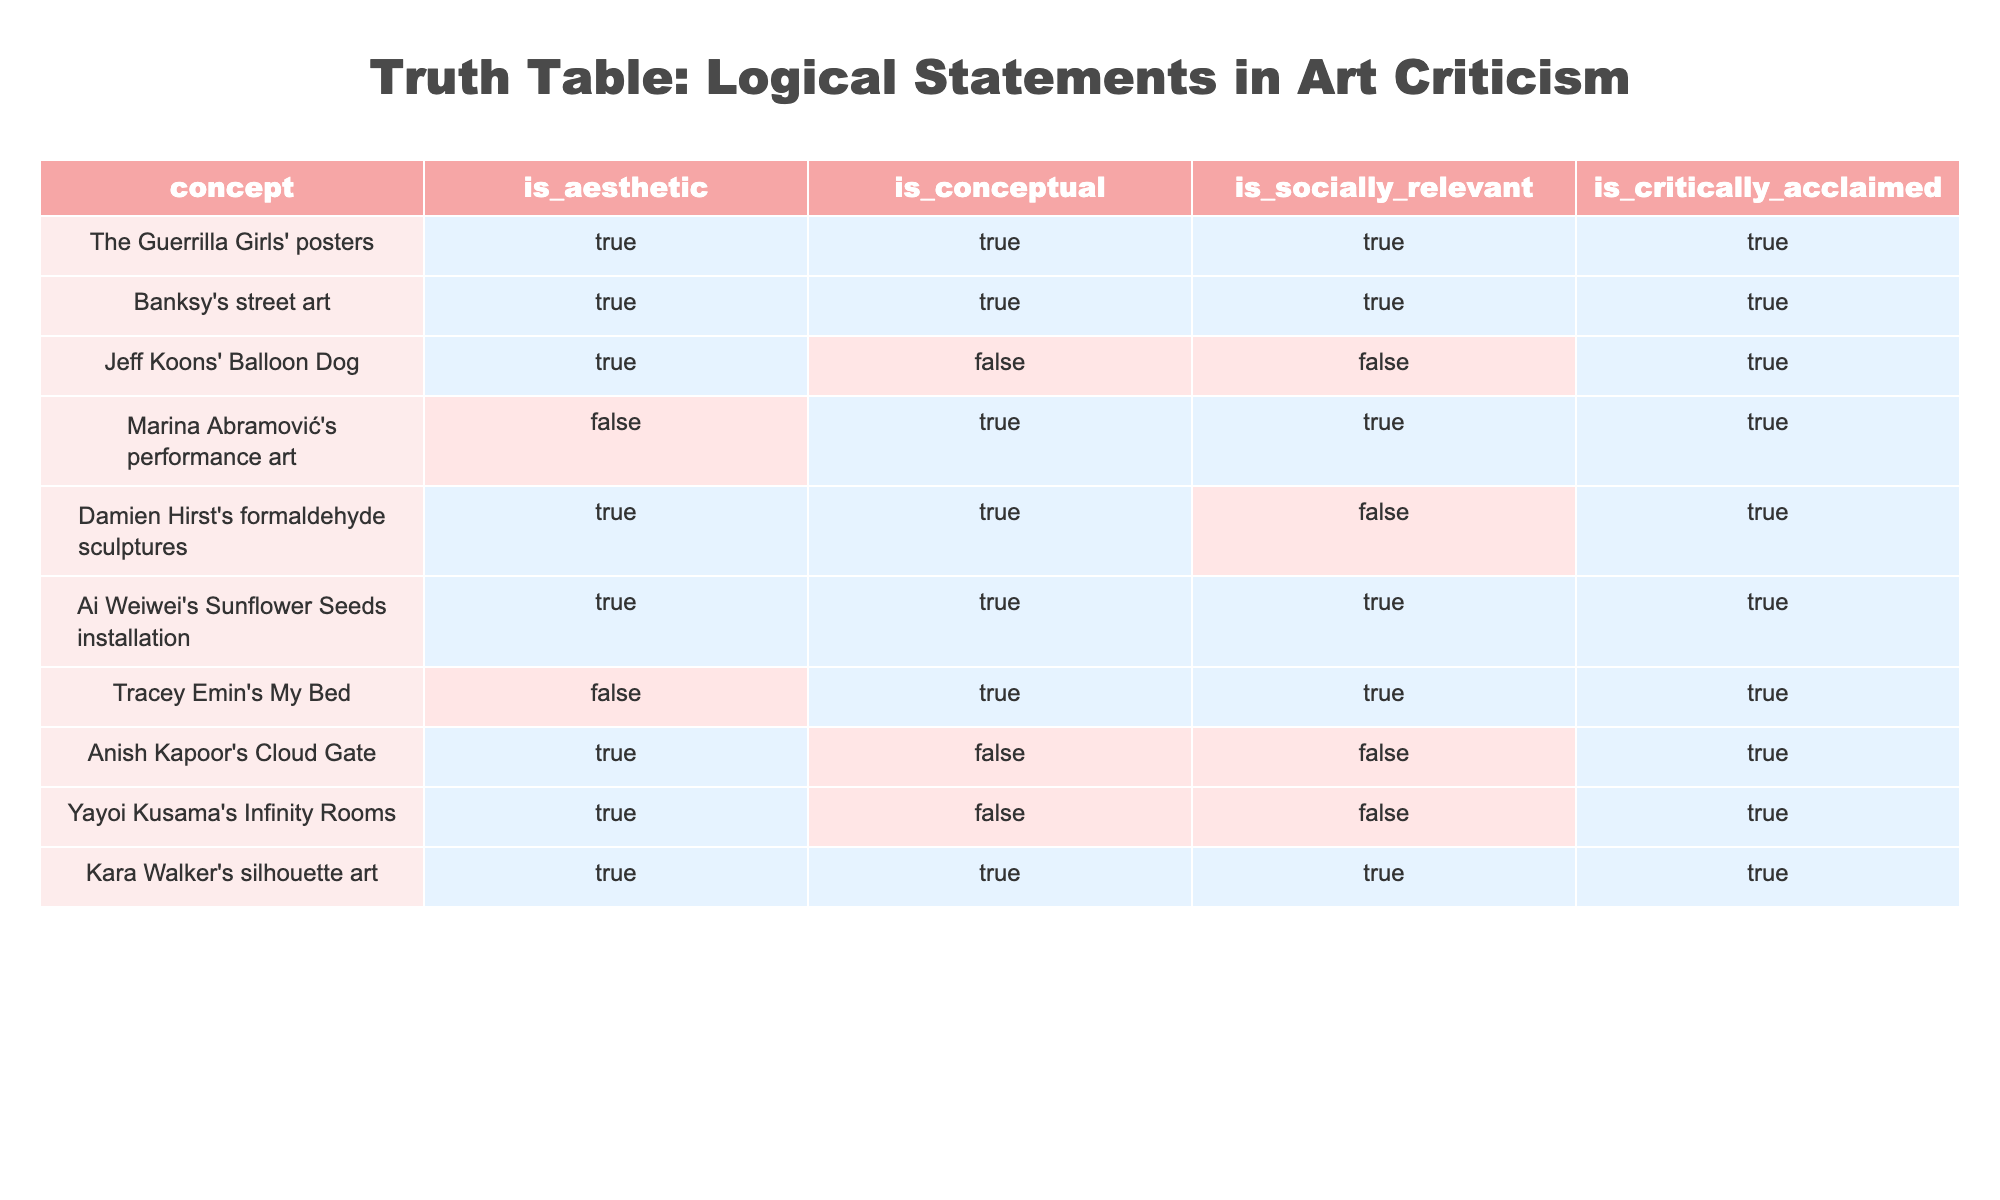What concepts are both aesthetic and socially relevant? To find the concepts that are both aesthetic and socially relevant, I check the columns for "is_aesthetic" and "is_socially_relevant". These must both have a value of true. The rows that meet this criterion are "The Guerrilla Girls' posters", "Banksy's street art", "Ai Weiwei's Sunflower Seeds installation", and "Kara Walker's silhouette art".
Answer: The Guerrilla Girls' posters, Banksy's street art, Ai Weiwei's Sunflower Seeds installation, Kara Walker's silhouette art How many concepts are not considered aesthetic? I look at the "is_aesthetic" column for the concepts that are marked false. These are "Marina Abramović's performance art", "Tracey Emin's My Bed", "Jeff Koons' Balloon Dog", "Anish Kapoor's Cloud Gate", and "Yayoi Kusama's Infinity Rooms". Counting them gives a total of five concepts.
Answer: 5 Is "Damien Hirst's formaldehyde sculptures" critically acclaimed? I reference the "is_critically_acclaimed" column for the row corresponding to "Damien Hirst's formaldehyde sculptures". It shows a value of true, indicating that it is critically acclaimed.
Answer: Yes Which concept has the highest number of true values across the "is_aesthetic", "is_conceptual", "is_socially_relevant", and "is_critically_acclaimed" columns? I count the true values for each concept in those four categories. "The Guerrilla Girls' posters", "Banksy's street art", "Ai Weiwei's Sunflower Seeds installation", and "Kara Walker's silhouette art" all have four true values. Thus, they share the highest count.
Answer: The Guerrilla Girls' posters, Banksy's street art, Ai Weiwei's Sunflower Seeds installation, Kara Walker's silhouette art Are there any concepts that are both conceptual and not aesthetically pleasing? I need to find concepts where "is_conceptual" is true and "is_aesthetic" is false. The rows that match are "Jeff Koons' Balloon Dog", "Marina Abramović's performance art", and "Tracey Emin's My Bed". Therefore, these three are not aesthetically pleasing.
Answer: Yes,  Jeff Koons' Balloon Dog, Marina Abramović's performance art, Tracey Emin's My Bed What proportion of concepts are socially relevant? To find this, I count the number of rows where "is_socially_relevant" is true. There are seven concepts that are socially relevant out of ten total concepts. Thus, the proportion is 7 out of 10, which equals 0.7 or 70%.
Answer: 70% 